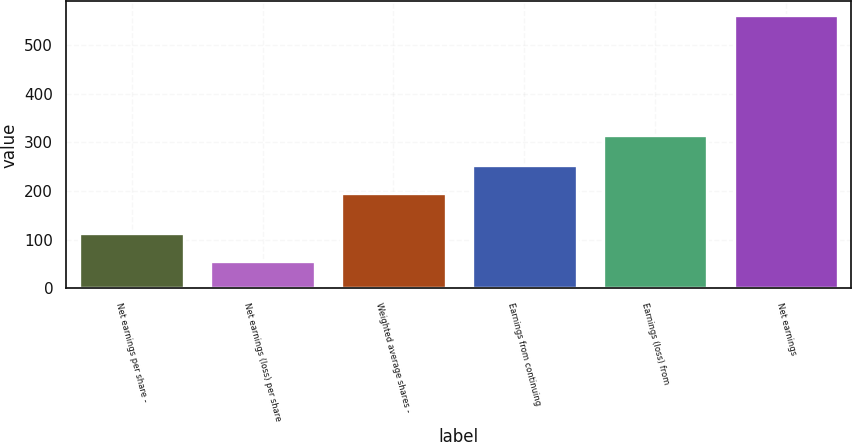Convert chart to OTSL. <chart><loc_0><loc_0><loc_500><loc_500><bar_chart><fcel>Net earnings per share -<fcel>Net earnings (loss) per share<fcel>Weighted average shares -<fcel>Earnings from continuing<fcel>Earnings (loss) from<fcel>Net earnings<nl><fcel>113.25<fcel>57.25<fcel>196.5<fcel>252.5<fcel>314.9<fcel>561.2<nl></chart> 